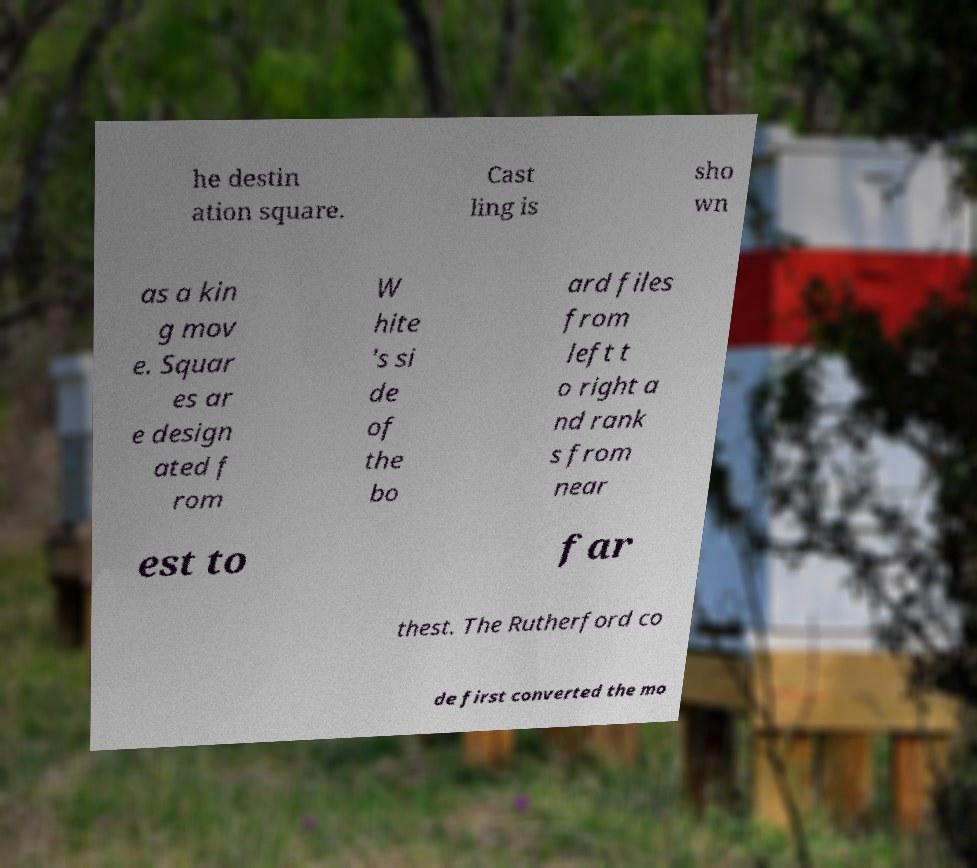What messages or text are displayed in this image? I need them in a readable, typed format. he destin ation square. Cast ling is sho wn as a kin g mov e. Squar es ar e design ated f rom W hite 's si de of the bo ard files from left t o right a nd rank s from near est to far thest. The Rutherford co de first converted the mo 